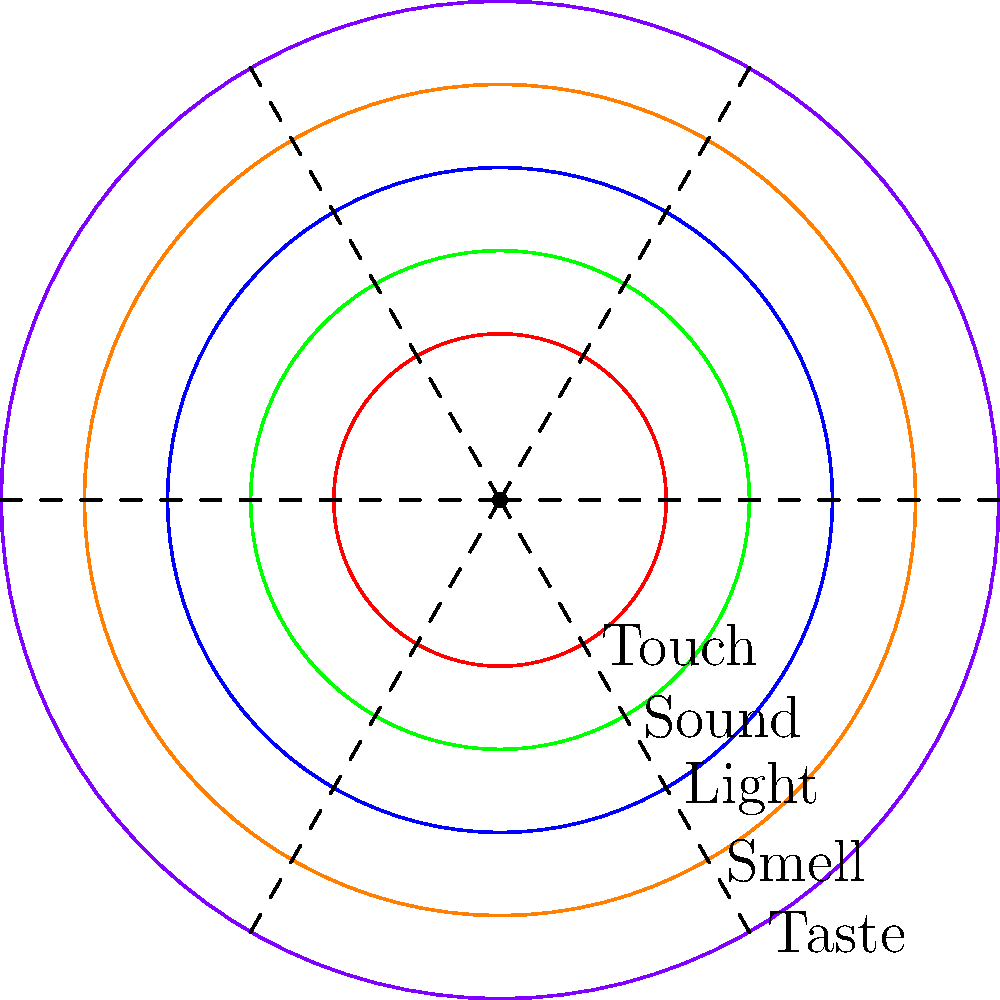In a study on sensory perception thresholds in individuals with autism spectrum disorders, you've plotted the average thresholds for five sensory modalities on a polar graph. Each concentric circle represents an increasing threshold level, with the center being the lowest. If the graph shows that the threshold for auditory stimuli (sound) is represented by the second innermost circle, what is the relative position of the olfactory (smell) threshold compared to auditory? To solve this problem, we need to analyze the polar graph and interpret the relative positions of the sensory thresholds:

1. Identify the sensory modalities:
   - The graph shows five sensory modalities: Touch, Sound, Light, Smell, and Taste.

2. Locate the auditory (sound) threshold:
   - The question states that the auditory threshold is represented by the second innermost circle.
   - This corresponds to the green circle on the graph.

3. Identify the olfactory (smell) threshold:
   - The orange circle represents the smell threshold.

4. Compare the relative positions:
   - The auditory (green) circle is the second from the center.
   - The olfactory (orange) circle is the fourth from the center.
   - This means the olfactory threshold is two levels higher than the auditory threshold.

5. Interpret the results:
   - A higher threshold indicates that a stronger stimulus is needed for perception.
   - Therefore, the olfactory threshold is higher than the auditory threshold.

In conclusion, the olfactory (smell) threshold is two levels higher than the auditory (sound) threshold, indicating a reduced sensitivity to olfactory stimuli compared to auditory stimuli in the studied population.
Answer: Two levels higher 